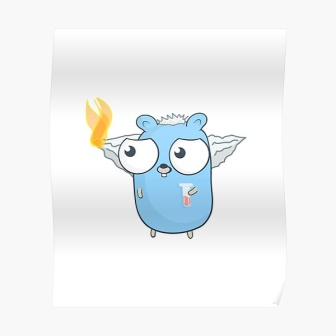Imagine this creature participating in a festival in its world. What might it look like? In the heart of Whispering Woods, the creature participates in the annual Luminara Festival—a grand celebration of light and life. Adorned with garlands of glowing vines, it joins other forest dwellers in an enchanting procession. Lanterns, shaped like mystical creatures, float above, lighting up the night sky. There’s music in the air, with melodies played on instruments made of natural elements like hollowed-out logs and water-filled reeds. Stalls laden with fantastical foods and potions line the path, offering treats that sparkle and fizz. An ethereal dance takes place, with the creature flitting gracefully, its wings catching and reflecting the ambient glow. As the night deepens, the flame on its head burns brighter, symbolizing the essence of the festival—hope, unity, and the magical bond shared among the forest inhabitants. 